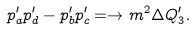<formula> <loc_0><loc_0><loc_500><loc_500>p _ { a } ^ { \prime } p _ { d } ^ { \prime } - p _ { b } ^ { \prime } p _ { c } ^ { \prime } = \to m ^ { 2 } \Delta Q _ { 3 } ^ { \prime } .</formula> 